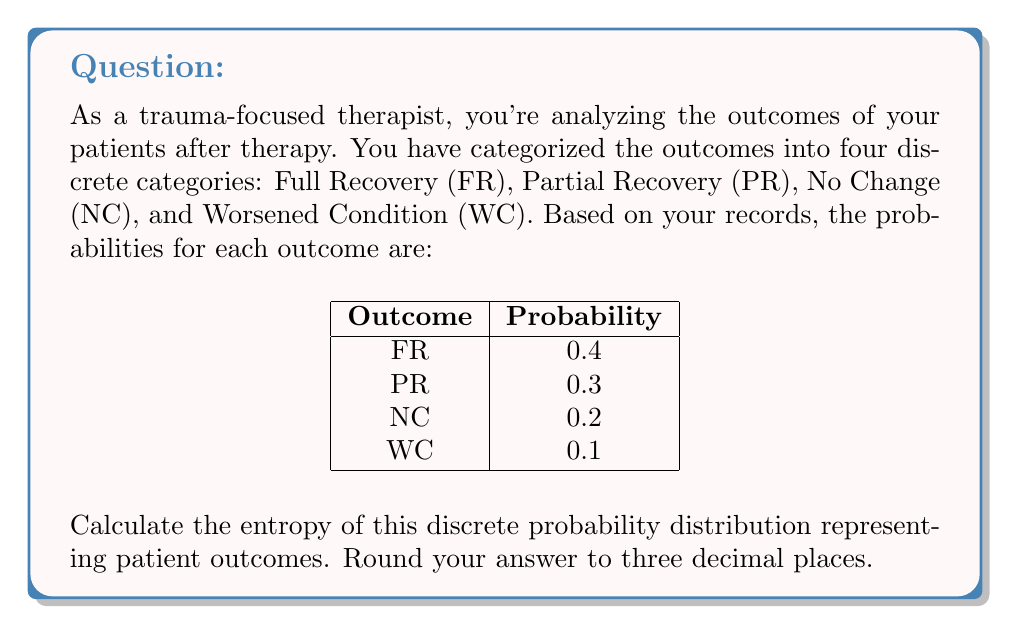Can you answer this question? To calculate the entropy of a discrete probability distribution, we use the formula:

$$H = -\sum_{i=1}^{n} p_i \log_2(p_i)$$

Where $H$ is the entropy, $p_i$ is the probability of each outcome, and $n$ is the number of possible outcomes.

Let's calculate for each outcome:

1. FR: $-0.4 \log_2(0.4) = 0.528321$
2. PR: $-0.3 \log_2(0.3) = 0.521448$
3. NC: $-0.2 \log_2(0.2) = 0.464386$
4. WC: $-0.1 \log_2(0.1) = 0.332193$

Now, sum these values:

$$H = 0.528321 + 0.521448 + 0.464386 + 0.332193 = 1.846348$$

Rounding to three decimal places: 1.846
Answer: 1.846 bits 